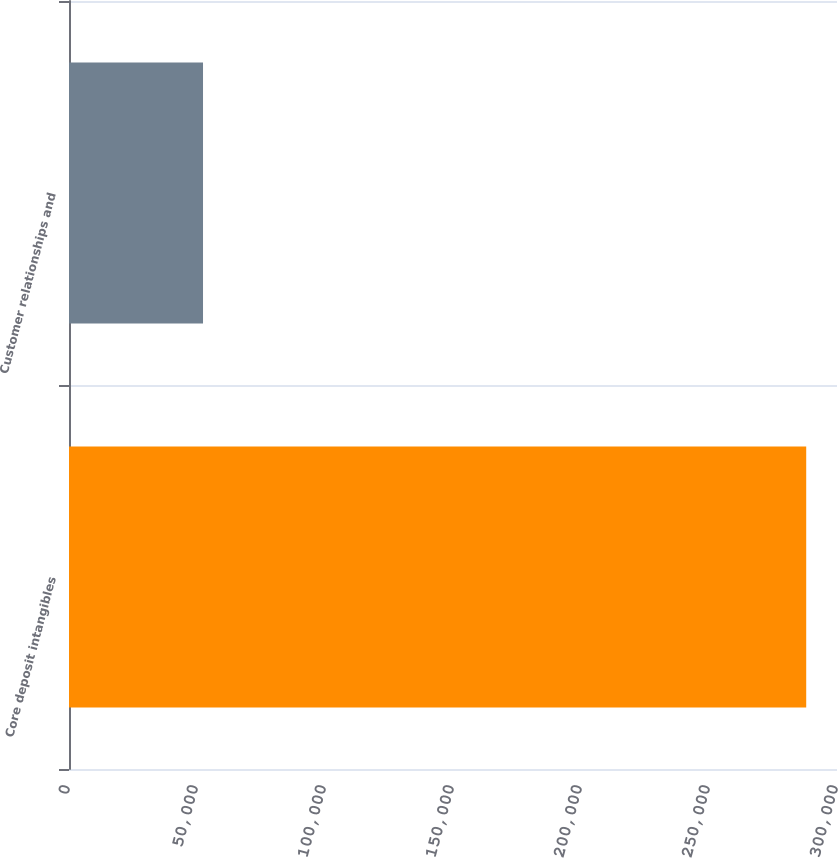<chart> <loc_0><loc_0><loc_500><loc_500><bar_chart><fcel>Core deposit intangibles<fcel>Customer relationships and<nl><fcel>287973<fcel>52350<nl></chart> 